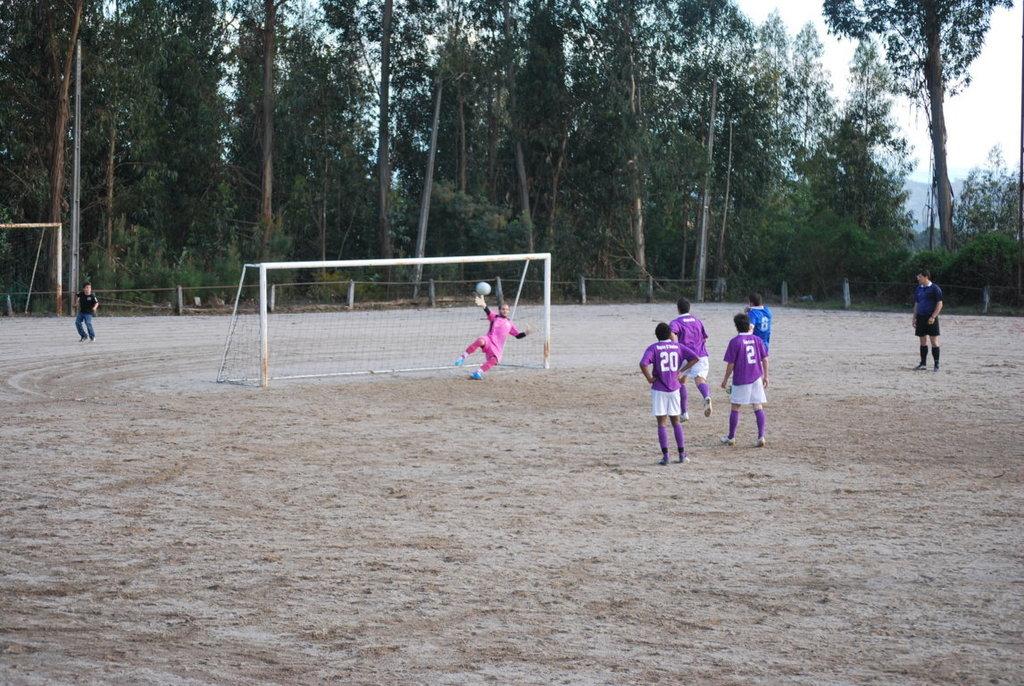What number is on the boy's jersey on the far left?
Offer a very short reply. 20. 